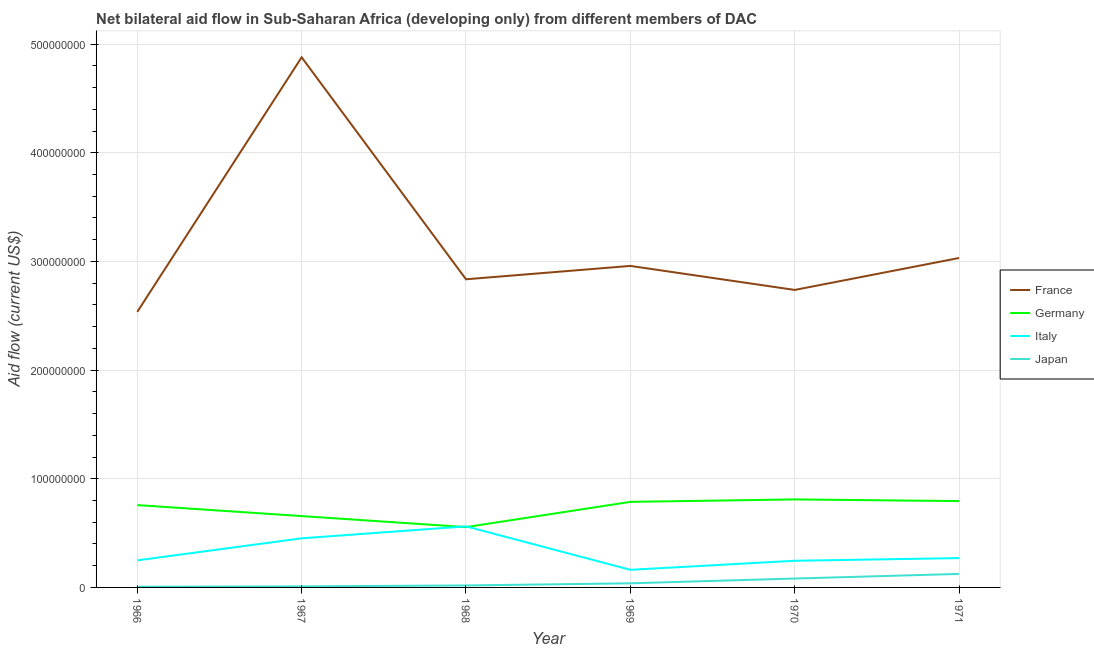How many different coloured lines are there?
Make the answer very short. 4. Is the number of lines equal to the number of legend labels?
Keep it short and to the point. Yes. What is the amount of aid given by italy in 1971?
Provide a succinct answer. 2.70e+07. Across all years, what is the maximum amount of aid given by france?
Your response must be concise. 4.88e+08. Across all years, what is the minimum amount of aid given by germany?
Provide a succinct answer. 5.55e+07. In which year was the amount of aid given by france maximum?
Provide a succinct answer. 1967. In which year was the amount of aid given by germany minimum?
Provide a short and direct response. 1968. What is the total amount of aid given by italy in the graph?
Offer a terse response. 1.94e+08. What is the difference between the amount of aid given by japan in 1966 and that in 1971?
Keep it short and to the point. -1.18e+07. What is the difference between the amount of aid given by france in 1971 and the amount of aid given by germany in 1968?
Offer a terse response. 2.48e+08. What is the average amount of aid given by italy per year?
Offer a very short reply. 3.23e+07. In the year 1967, what is the difference between the amount of aid given by italy and amount of aid given by japan?
Your answer should be compact. 4.42e+07. In how many years, is the amount of aid given by germany greater than 400000000 US$?
Give a very brief answer. 0. What is the ratio of the amount of aid given by france in 1967 to that in 1969?
Offer a terse response. 1.65. Is the amount of aid given by germany in 1969 less than that in 1971?
Provide a short and direct response. Yes. What is the difference between the highest and the second highest amount of aid given by japan?
Provide a short and direct response. 4.24e+06. What is the difference between the highest and the lowest amount of aid given by italy?
Give a very brief answer. 4.00e+07. Is the sum of the amount of aid given by germany in 1970 and 1971 greater than the maximum amount of aid given by italy across all years?
Provide a short and direct response. Yes. Is it the case that in every year, the sum of the amount of aid given by japan and amount of aid given by germany is greater than the sum of amount of aid given by italy and amount of aid given by france?
Your response must be concise. No. Is it the case that in every year, the sum of the amount of aid given by france and amount of aid given by germany is greater than the amount of aid given by italy?
Make the answer very short. Yes. Does the amount of aid given by japan monotonically increase over the years?
Your answer should be very brief. Yes. Is the amount of aid given by germany strictly greater than the amount of aid given by japan over the years?
Your answer should be compact. Yes. How many lines are there?
Ensure brevity in your answer.  4. How are the legend labels stacked?
Provide a succinct answer. Vertical. What is the title of the graph?
Give a very brief answer. Net bilateral aid flow in Sub-Saharan Africa (developing only) from different members of DAC. Does "Source data assessment" appear as one of the legend labels in the graph?
Offer a very short reply. No. What is the label or title of the X-axis?
Offer a terse response. Year. What is the label or title of the Y-axis?
Make the answer very short. Aid flow (current US$). What is the Aid flow (current US$) in France in 1966?
Ensure brevity in your answer.  2.54e+08. What is the Aid flow (current US$) of Germany in 1966?
Provide a short and direct response. 7.58e+07. What is the Aid flow (current US$) of Italy in 1966?
Make the answer very short. 2.49e+07. What is the Aid flow (current US$) of Japan in 1966?
Your response must be concise. 6.60e+05. What is the Aid flow (current US$) in France in 1967?
Provide a succinct answer. 4.88e+08. What is the Aid flow (current US$) of Germany in 1967?
Make the answer very short. 6.57e+07. What is the Aid flow (current US$) in Italy in 1967?
Give a very brief answer. 4.52e+07. What is the Aid flow (current US$) in Japan in 1967?
Offer a terse response. 9.70e+05. What is the Aid flow (current US$) of France in 1968?
Offer a terse response. 2.84e+08. What is the Aid flow (current US$) of Germany in 1968?
Offer a terse response. 5.55e+07. What is the Aid flow (current US$) of Italy in 1968?
Provide a short and direct response. 5.62e+07. What is the Aid flow (current US$) in Japan in 1968?
Your answer should be compact. 1.82e+06. What is the Aid flow (current US$) in France in 1969?
Provide a short and direct response. 2.96e+08. What is the Aid flow (current US$) in Germany in 1969?
Provide a short and direct response. 7.88e+07. What is the Aid flow (current US$) in Italy in 1969?
Provide a short and direct response. 1.62e+07. What is the Aid flow (current US$) in Japan in 1969?
Your response must be concise. 3.79e+06. What is the Aid flow (current US$) in France in 1970?
Your response must be concise. 2.74e+08. What is the Aid flow (current US$) of Germany in 1970?
Provide a succinct answer. 8.10e+07. What is the Aid flow (current US$) in Italy in 1970?
Offer a very short reply. 2.45e+07. What is the Aid flow (current US$) of Japan in 1970?
Make the answer very short. 8.19e+06. What is the Aid flow (current US$) of France in 1971?
Your answer should be very brief. 3.03e+08. What is the Aid flow (current US$) in Germany in 1971?
Provide a short and direct response. 7.94e+07. What is the Aid flow (current US$) in Italy in 1971?
Your response must be concise. 2.70e+07. What is the Aid flow (current US$) of Japan in 1971?
Provide a succinct answer. 1.24e+07. Across all years, what is the maximum Aid flow (current US$) of France?
Your answer should be very brief. 4.88e+08. Across all years, what is the maximum Aid flow (current US$) of Germany?
Your answer should be compact. 8.10e+07. Across all years, what is the maximum Aid flow (current US$) of Italy?
Provide a succinct answer. 5.62e+07. Across all years, what is the maximum Aid flow (current US$) in Japan?
Give a very brief answer. 1.24e+07. Across all years, what is the minimum Aid flow (current US$) of France?
Give a very brief answer. 2.54e+08. Across all years, what is the minimum Aid flow (current US$) in Germany?
Offer a terse response. 5.55e+07. Across all years, what is the minimum Aid flow (current US$) in Italy?
Provide a succinct answer. 1.62e+07. Across all years, what is the minimum Aid flow (current US$) in Japan?
Ensure brevity in your answer.  6.60e+05. What is the total Aid flow (current US$) of France in the graph?
Provide a short and direct response. 1.90e+09. What is the total Aid flow (current US$) in Germany in the graph?
Your response must be concise. 4.36e+08. What is the total Aid flow (current US$) in Italy in the graph?
Provide a short and direct response. 1.94e+08. What is the total Aid flow (current US$) of Japan in the graph?
Keep it short and to the point. 2.79e+07. What is the difference between the Aid flow (current US$) in France in 1966 and that in 1967?
Offer a terse response. -2.34e+08. What is the difference between the Aid flow (current US$) of Germany in 1966 and that in 1967?
Give a very brief answer. 1.01e+07. What is the difference between the Aid flow (current US$) in Italy in 1966 and that in 1967?
Keep it short and to the point. -2.03e+07. What is the difference between the Aid flow (current US$) in Japan in 1966 and that in 1967?
Keep it short and to the point. -3.10e+05. What is the difference between the Aid flow (current US$) of France in 1966 and that in 1968?
Ensure brevity in your answer.  -3.00e+07. What is the difference between the Aid flow (current US$) of Germany in 1966 and that in 1968?
Offer a terse response. 2.03e+07. What is the difference between the Aid flow (current US$) of Italy in 1966 and that in 1968?
Offer a terse response. -3.13e+07. What is the difference between the Aid flow (current US$) of Japan in 1966 and that in 1968?
Ensure brevity in your answer.  -1.16e+06. What is the difference between the Aid flow (current US$) in France in 1966 and that in 1969?
Your answer should be very brief. -4.23e+07. What is the difference between the Aid flow (current US$) of Germany in 1966 and that in 1969?
Keep it short and to the point. -2.97e+06. What is the difference between the Aid flow (current US$) in Italy in 1966 and that in 1969?
Ensure brevity in your answer.  8.69e+06. What is the difference between the Aid flow (current US$) of Japan in 1966 and that in 1969?
Your answer should be very brief. -3.13e+06. What is the difference between the Aid flow (current US$) of France in 1966 and that in 1970?
Provide a short and direct response. -2.02e+07. What is the difference between the Aid flow (current US$) of Germany in 1966 and that in 1970?
Provide a succinct answer. -5.22e+06. What is the difference between the Aid flow (current US$) of Italy in 1966 and that in 1970?
Provide a succinct answer. 3.80e+05. What is the difference between the Aid flow (current US$) in Japan in 1966 and that in 1970?
Keep it short and to the point. -7.53e+06. What is the difference between the Aid flow (current US$) in France in 1966 and that in 1971?
Provide a short and direct response. -4.96e+07. What is the difference between the Aid flow (current US$) of Germany in 1966 and that in 1971?
Your answer should be very brief. -3.67e+06. What is the difference between the Aid flow (current US$) in Italy in 1966 and that in 1971?
Give a very brief answer. -2.08e+06. What is the difference between the Aid flow (current US$) of Japan in 1966 and that in 1971?
Offer a terse response. -1.18e+07. What is the difference between the Aid flow (current US$) in France in 1967 and that in 1968?
Your answer should be compact. 2.04e+08. What is the difference between the Aid flow (current US$) in Germany in 1967 and that in 1968?
Your answer should be very brief. 1.02e+07. What is the difference between the Aid flow (current US$) of Italy in 1967 and that in 1968?
Make the answer very short. -1.10e+07. What is the difference between the Aid flow (current US$) in Japan in 1967 and that in 1968?
Your answer should be very brief. -8.50e+05. What is the difference between the Aid flow (current US$) in France in 1967 and that in 1969?
Your response must be concise. 1.92e+08. What is the difference between the Aid flow (current US$) in Germany in 1967 and that in 1969?
Make the answer very short. -1.31e+07. What is the difference between the Aid flow (current US$) of Italy in 1967 and that in 1969?
Give a very brief answer. 2.90e+07. What is the difference between the Aid flow (current US$) of Japan in 1967 and that in 1969?
Give a very brief answer. -2.82e+06. What is the difference between the Aid flow (current US$) of France in 1967 and that in 1970?
Your answer should be compact. 2.14e+08. What is the difference between the Aid flow (current US$) in Germany in 1967 and that in 1970?
Make the answer very short. -1.53e+07. What is the difference between the Aid flow (current US$) in Italy in 1967 and that in 1970?
Your answer should be compact. 2.07e+07. What is the difference between the Aid flow (current US$) in Japan in 1967 and that in 1970?
Offer a very short reply. -7.22e+06. What is the difference between the Aid flow (current US$) of France in 1967 and that in 1971?
Your answer should be compact. 1.85e+08. What is the difference between the Aid flow (current US$) of Germany in 1967 and that in 1971?
Give a very brief answer. -1.38e+07. What is the difference between the Aid flow (current US$) in Italy in 1967 and that in 1971?
Offer a terse response. 1.82e+07. What is the difference between the Aid flow (current US$) in Japan in 1967 and that in 1971?
Your answer should be compact. -1.15e+07. What is the difference between the Aid flow (current US$) in France in 1968 and that in 1969?
Offer a terse response. -1.23e+07. What is the difference between the Aid flow (current US$) in Germany in 1968 and that in 1969?
Give a very brief answer. -2.32e+07. What is the difference between the Aid flow (current US$) in Italy in 1968 and that in 1969?
Your answer should be very brief. 4.00e+07. What is the difference between the Aid flow (current US$) of Japan in 1968 and that in 1969?
Ensure brevity in your answer.  -1.97e+06. What is the difference between the Aid flow (current US$) of France in 1968 and that in 1970?
Provide a succinct answer. 9.80e+06. What is the difference between the Aid flow (current US$) in Germany in 1968 and that in 1970?
Ensure brevity in your answer.  -2.55e+07. What is the difference between the Aid flow (current US$) in Italy in 1968 and that in 1970?
Provide a succinct answer. 3.17e+07. What is the difference between the Aid flow (current US$) of Japan in 1968 and that in 1970?
Give a very brief answer. -6.37e+06. What is the difference between the Aid flow (current US$) in France in 1968 and that in 1971?
Offer a very short reply. -1.96e+07. What is the difference between the Aid flow (current US$) of Germany in 1968 and that in 1971?
Give a very brief answer. -2.39e+07. What is the difference between the Aid flow (current US$) in Italy in 1968 and that in 1971?
Provide a succinct answer. 2.92e+07. What is the difference between the Aid flow (current US$) of Japan in 1968 and that in 1971?
Keep it short and to the point. -1.06e+07. What is the difference between the Aid flow (current US$) in France in 1969 and that in 1970?
Provide a succinct answer. 2.21e+07. What is the difference between the Aid flow (current US$) in Germany in 1969 and that in 1970?
Your answer should be very brief. -2.25e+06. What is the difference between the Aid flow (current US$) of Italy in 1969 and that in 1970?
Offer a very short reply. -8.31e+06. What is the difference between the Aid flow (current US$) in Japan in 1969 and that in 1970?
Give a very brief answer. -4.40e+06. What is the difference between the Aid flow (current US$) in France in 1969 and that in 1971?
Make the answer very short. -7.30e+06. What is the difference between the Aid flow (current US$) in Germany in 1969 and that in 1971?
Offer a terse response. -7.00e+05. What is the difference between the Aid flow (current US$) of Italy in 1969 and that in 1971?
Give a very brief answer. -1.08e+07. What is the difference between the Aid flow (current US$) in Japan in 1969 and that in 1971?
Your response must be concise. -8.64e+06. What is the difference between the Aid flow (current US$) in France in 1970 and that in 1971?
Offer a very short reply. -2.94e+07. What is the difference between the Aid flow (current US$) of Germany in 1970 and that in 1971?
Your answer should be very brief. 1.55e+06. What is the difference between the Aid flow (current US$) in Italy in 1970 and that in 1971?
Keep it short and to the point. -2.46e+06. What is the difference between the Aid flow (current US$) of Japan in 1970 and that in 1971?
Ensure brevity in your answer.  -4.24e+06. What is the difference between the Aid flow (current US$) in France in 1966 and the Aid flow (current US$) in Germany in 1967?
Your answer should be very brief. 1.88e+08. What is the difference between the Aid flow (current US$) in France in 1966 and the Aid flow (current US$) in Italy in 1967?
Make the answer very short. 2.08e+08. What is the difference between the Aid flow (current US$) in France in 1966 and the Aid flow (current US$) in Japan in 1967?
Provide a short and direct response. 2.53e+08. What is the difference between the Aid flow (current US$) in Germany in 1966 and the Aid flow (current US$) in Italy in 1967?
Your response must be concise. 3.06e+07. What is the difference between the Aid flow (current US$) in Germany in 1966 and the Aid flow (current US$) in Japan in 1967?
Provide a short and direct response. 7.48e+07. What is the difference between the Aid flow (current US$) in Italy in 1966 and the Aid flow (current US$) in Japan in 1967?
Offer a very short reply. 2.40e+07. What is the difference between the Aid flow (current US$) in France in 1966 and the Aid flow (current US$) in Germany in 1968?
Keep it short and to the point. 1.98e+08. What is the difference between the Aid flow (current US$) in France in 1966 and the Aid flow (current US$) in Italy in 1968?
Offer a terse response. 1.97e+08. What is the difference between the Aid flow (current US$) in France in 1966 and the Aid flow (current US$) in Japan in 1968?
Give a very brief answer. 2.52e+08. What is the difference between the Aid flow (current US$) in Germany in 1966 and the Aid flow (current US$) in Italy in 1968?
Ensure brevity in your answer.  1.96e+07. What is the difference between the Aid flow (current US$) in Germany in 1966 and the Aid flow (current US$) in Japan in 1968?
Offer a very short reply. 7.40e+07. What is the difference between the Aid flow (current US$) in Italy in 1966 and the Aid flow (current US$) in Japan in 1968?
Offer a terse response. 2.31e+07. What is the difference between the Aid flow (current US$) in France in 1966 and the Aid flow (current US$) in Germany in 1969?
Keep it short and to the point. 1.75e+08. What is the difference between the Aid flow (current US$) in France in 1966 and the Aid flow (current US$) in Italy in 1969?
Give a very brief answer. 2.37e+08. What is the difference between the Aid flow (current US$) of France in 1966 and the Aid flow (current US$) of Japan in 1969?
Your answer should be very brief. 2.50e+08. What is the difference between the Aid flow (current US$) in Germany in 1966 and the Aid flow (current US$) in Italy in 1969?
Your answer should be compact. 5.96e+07. What is the difference between the Aid flow (current US$) in Germany in 1966 and the Aid flow (current US$) in Japan in 1969?
Offer a terse response. 7.20e+07. What is the difference between the Aid flow (current US$) of Italy in 1966 and the Aid flow (current US$) of Japan in 1969?
Make the answer very short. 2.11e+07. What is the difference between the Aid flow (current US$) in France in 1966 and the Aid flow (current US$) in Germany in 1970?
Provide a succinct answer. 1.73e+08. What is the difference between the Aid flow (current US$) of France in 1966 and the Aid flow (current US$) of Italy in 1970?
Keep it short and to the point. 2.29e+08. What is the difference between the Aid flow (current US$) of France in 1966 and the Aid flow (current US$) of Japan in 1970?
Keep it short and to the point. 2.45e+08. What is the difference between the Aid flow (current US$) in Germany in 1966 and the Aid flow (current US$) in Italy in 1970?
Your answer should be very brief. 5.12e+07. What is the difference between the Aid flow (current US$) in Germany in 1966 and the Aid flow (current US$) in Japan in 1970?
Keep it short and to the point. 6.76e+07. What is the difference between the Aid flow (current US$) of Italy in 1966 and the Aid flow (current US$) of Japan in 1970?
Your answer should be compact. 1.67e+07. What is the difference between the Aid flow (current US$) in France in 1966 and the Aid flow (current US$) in Germany in 1971?
Give a very brief answer. 1.74e+08. What is the difference between the Aid flow (current US$) of France in 1966 and the Aid flow (current US$) of Italy in 1971?
Your response must be concise. 2.27e+08. What is the difference between the Aid flow (current US$) in France in 1966 and the Aid flow (current US$) in Japan in 1971?
Your answer should be compact. 2.41e+08. What is the difference between the Aid flow (current US$) in Germany in 1966 and the Aid flow (current US$) in Italy in 1971?
Offer a terse response. 4.88e+07. What is the difference between the Aid flow (current US$) in Germany in 1966 and the Aid flow (current US$) in Japan in 1971?
Your answer should be compact. 6.34e+07. What is the difference between the Aid flow (current US$) of Italy in 1966 and the Aid flow (current US$) of Japan in 1971?
Offer a terse response. 1.25e+07. What is the difference between the Aid flow (current US$) in France in 1967 and the Aid flow (current US$) in Germany in 1968?
Ensure brevity in your answer.  4.32e+08. What is the difference between the Aid flow (current US$) in France in 1967 and the Aid flow (current US$) in Italy in 1968?
Ensure brevity in your answer.  4.32e+08. What is the difference between the Aid flow (current US$) in France in 1967 and the Aid flow (current US$) in Japan in 1968?
Give a very brief answer. 4.86e+08. What is the difference between the Aid flow (current US$) of Germany in 1967 and the Aid flow (current US$) of Italy in 1968?
Your answer should be compact. 9.46e+06. What is the difference between the Aid flow (current US$) in Germany in 1967 and the Aid flow (current US$) in Japan in 1968?
Your response must be concise. 6.38e+07. What is the difference between the Aid flow (current US$) of Italy in 1967 and the Aid flow (current US$) of Japan in 1968?
Provide a short and direct response. 4.34e+07. What is the difference between the Aid flow (current US$) in France in 1967 and the Aid flow (current US$) in Germany in 1969?
Your answer should be very brief. 4.09e+08. What is the difference between the Aid flow (current US$) in France in 1967 and the Aid flow (current US$) in Italy in 1969?
Give a very brief answer. 4.72e+08. What is the difference between the Aid flow (current US$) of France in 1967 and the Aid flow (current US$) of Japan in 1969?
Your response must be concise. 4.84e+08. What is the difference between the Aid flow (current US$) of Germany in 1967 and the Aid flow (current US$) of Italy in 1969?
Provide a succinct answer. 4.94e+07. What is the difference between the Aid flow (current US$) in Germany in 1967 and the Aid flow (current US$) in Japan in 1969?
Make the answer very short. 6.19e+07. What is the difference between the Aid flow (current US$) in Italy in 1967 and the Aid flow (current US$) in Japan in 1969?
Offer a terse response. 4.14e+07. What is the difference between the Aid flow (current US$) in France in 1967 and the Aid flow (current US$) in Germany in 1970?
Your response must be concise. 4.07e+08. What is the difference between the Aid flow (current US$) of France in 1967 and the Aid flow (current US$) of Italy in 1970?
Ensure brevity in your answer.  4.63e+08. What is the difference between the Aid flow (current US$) in France in 1967 and the Aid flow (current US$) in Japan in 1970?
Your answer should be compact. 4.80e+08. What is the difference between the Aid flow (current US$) in Germany in 1967 and the Aid flow (current US$) in Italy in 1970?
Ensure brevity in your answer.  4.11e+07. What is the difference between the Aid flow (current US$) of Germany in 1967 and the Aid flow (current US$) of Japan in 1970?
Your answer should be very brief. 5.75e+07. What is the difference between the Aid flow (current US$) of Italy in 1967 and the Aid flow (current US$) of Japan in 1970?
Your response must be concise. 3.70e+07. What is the difference between the Aid flow (current US$) of France in 1967 and the Aid flow (current US$) of Germany in 1971?
Offer a very short reply. 4.08e+08. What is the difference between the Aid flow (current US$) of France in 1967 and the Aid flow (current US$) of Italy in 1971?
Offer a terse response. 4.61e+08. What is the difference between the Aid flow (current US$) of France in 1967 and the Aid flow (current US$) of Japan in 1971?
Your answer should be very brief. 4.75e+08. What is the difference between the Aid flow (current US$) in Germany in 1967 and the Aid flow (current US$) in Italy in 1971?
Your answer should be compact. 3.87e+07. What is the difference between the Aid flow (current US$) of Germany in 1967 and the Aid flow (current US$) of Japan in 1971?
Provide a succinct answer. 5.32e+07. What is the difference between the Aid flow (current US$) of Italy in 1967 and the Aid flow (current US$) of Japan in 1971?
Make the answer very short. 3.28e+07. What is the difference between the Aid flow (current US$) of France in 1968 and the Aid flow (current US$) of Germany in 1969?
Ensure brevity in your answer.  2.05e+08. What is the difference between the Aid flow (current US$) of France in 1968 and the Aid flow (current US$) of Italy in 1969?
Provide a short and direct response. 2.67e+08. What is the difference between the Aid flow (current US$) of France in 1968 and the Aid flow (current US$) of Japan in 1969?
Make the answer very short. 2.80e+08. What is the difference between the Aid flow (current US$) in Germany in 1968 and the Aid flow (current US$) in Italy in 1969?
Offer a terse response. 3.93e+07. What is the difference between the Aid flow (current US$) of Germany in 1968 and the Aid flow (current US$) of Japan in 1969?
Offer a terse response. 5.17e+07. What is the difference between the Aid flow (current US$) in Italy in 1968 and the Aid flow (current US$) in Japan in 1969?
Your answer should be very brief. 5.24e+07. What is the difference between the Aid flow (current US$) in France in 1968 and the Aid flow (current US$) in Germany in 1970?
Give a very brief answer. 2.03e+08. What is the difference between the Aid flow (current US$) of France in 1968 and the Aid flow (current US$) of Italy in 1970?
Your answer should be compact. 2.59e+08. What is the difference between the Aid flow (current US$) of France in 1968 and the Aid flow (current US$) of Japan in 1970?
Your answer should be compact. 2.75e+08. What is the difference between the Aid flow (current US$) of Germany in 1968 and the Aid flow (current US$) of Italy in 1970?
Your answer should be compact. 3.10e+07. What is the difference between the Aid flow (current US$) of Germany in 1968 and the Aid flow (current US$) of Japan in 1970?
Make the answer very short. 4.73e+07. What is the difference between the Aid flow (current US$) in Italy in 1968 and the Aid flow (current US$) in Japan in 1970?
Your answer should be compact. 4.80e+07. What is the difference between the Aid flow (current US$) in France in 1968 and the Aid flow (current US$) in Germany in 1971?
Provide a short and direct response. 2.04e+08. What is the difference between the Aid flow (current US$) in France in 1968 and the Aid flow (current US$) in Italy in 1971?
Provide a succinct answer. 2.57e+08. What is the difference between the Aid flow (current US$) in France in 1968 and the Aid flow (current US$) in Japan in 1971?
Keep it short and to the point. 2.71e+08. What is the difference between the Aid flow (current US$) of Germany in 1968 and the Aid flow (current US$) of Italy in 1971?
Your answer should be compact. 2.85e+07. What is the difference between the Aid flow (current US$) in Germany in 1968 and the Aid flow (current US$) in Japan in 1971?
Offer a terse response. 4.31e+07. What is the difference between the Aid flow (current US$) of Italy in 1968 and the Aid flow (current US$) of Japan in 1971?
Make the answer very short. 4.38e+07. What is the difference between the Aid flow (current US$) of France in 1969 and the Aid flow (current US$) of Germany in 1970?
Provide a short and direct response. 2.15e+08. What is the difference between the Aid flow (current US$) in France in 1969 and the Aid flow (current US$) in Italy in 1970?
Provide a succinct answer. 2.71e+08. What is the difference between the Aid flow (current US$) in France in 1969 and the Aid flow (current US$) in Japan in 1970?
Offer a terse response. 2.88e+08. What is the difference between the Aid flow (current US$) in Germany in 1969 and the Aid flow (current US$) in Italy in 1970?
Offer a terse response. 5.42e+07. What is the difference between the Aid flow (current US$) of Germany in 1969 and the Aid flow (current US$) of Japan in 1970?
Your answer should be very brief. 7.06e+07. What is the difference between the Aid flow (current US$) of Italy in 1969 and the Aid flow (current US$) of Japan in 1970?
Your answer should be very brief. 8.04e+06. What is the difference between the Aid flow (current US$) of France in 1969 and the Aid flow (current US$) of Germany in 1971?
Provide a short and direct response. 2.16e+08. What is the difference between the Aid flow (current US$) in France in 1969 and the Aid flow (current US$) in Italy in 1971?
Provide a short and direct response. 2.69e+08. What is the difference between the Aid flow (current US$) in France in 1969 and the Aid flow (current US$) in Japan in 1971?
Offer a very short reply. 2.83e+08. What is the difference between the Aid flow (current US$) of Germany in 1969 and the Aid flow (current US$) of Italy in 1971?
Your answer should be very brief. 5.18e+07. What is the difference between the Aid flow (current US$) in Germany in 1969 and the Aid flow (current US$) in Japan in 1971?
Offer a very short reply. 6.63e+07. What is the difference between the Aid flow (current US$) in Italy in 1969 and the Aid flow (current US$) in Japan in 1971?
Provide a succinct answer. 3.80e+06. What is the difference between the Aid flow (current US$) of France in 1970 and the Aid flow (current US$) of Germany in 1971?
Your answer should be very brief. 1.94e+08. What is the difference between the Aid flow (current US$) of France in 1970 and the Aid flow (current US$) of Italy in 1971?
Make the answer very short. 2.47e+08. What is the difference between the Aid flow (current US$) in France in 1970 and the Aid flow (current US$) in Japan in 1971?
Your response must be concise. 2.61e+08. What is the difference between the Aid flow (current US$) of Germany in 1970 and the Aid flow (current US$) of Italy in 1971?
Provide a short and direct response. 5.40e+07. What is the difference between the Aid flow (current US$) of Germany in 1970 and the Aid flow (current US$) of Japan in 1971?
Give a very brief answer. 6.86e+07. What is the difference between the Aid flow (current US$) of Italy in 1970 and the Aid flow (current US$) of Japan in 1971?
Your answer should be compact. 1.21e+07. What is the average Aid flow (current US$) of France per year?
Your answer should be very brief. 3.16e+08. What is the average Aid flow (current US$) in Germany per year?
Offer a very short reply. 7.27e+07. What is the average Aid flow (current US$) of Italy per year?
Give a very brief answer. 3.23e+07. What is the average Aid flow (current US$) in Japan per year?
Ensure brevity in your answer.  4.64e+06. In the year 1966, what is the difference between the Aid flow (current US$) in France and Aid flow (current US$) in Germany?
Offer a terse response. 1.78e+08. In the year 1966, what is the difference between the Aid flow (current US$) of France and Aid flow (current US$) of Italy?
Your response must be concise. 2.29e+08. In the year 1966, what is the difference between the Aid flow (current US$) of France and Aid flow (current US$) of Japan?
Your answer should be very brief. 2.53e+08. In the year 1966, what is the difference between the Aid flow (current US$) in Germany and Aid flow (current US$) in Italy?
Keep it short and to the point. 5.09e+07. In the year 1966, what is the difference between the Aid flow (current US$) of Germany and Aid flow (current US$) of Japan?
Your answer should be compact. 7.51e+07. In the year 1966, what is the difference between the Aid flow (current US$) in Italy and Aid flow (current US$) in Japan?
Your answer should be compact. 2.43e+07. In the year 1967, what is the difference between the Aid flow (current US$) in France and Aid flow (current US$) in Germany?
Offer a terse response. 4.22e+08. In the year 1967, what is the difference between the Aid flow (current US$) of France and Aid flow (current US$) of Italy?
Your answer should be compact. 4.43e+08. In the year 1967, what is the difference between the Aid flow (current US$) of France and Aid flow (current US$) of Japan?
Your answer should be compact. 4.87e+08. In the year 1967, what is the difference between the Aid flow (current US$) in Germany and Aid flow (current US$) in Italy?
Offer a very short reply. 2.05e+07. In the year 1967, what is the difference between the Aid flow (current US$) in Germany and Aid flow (current US$) in Japan?
Offer a terse response. 6.47e+07. In the year 1967, what is the difference between the Aid flow (current US$) of Italy and Aid flow (current US$) of Japan?
Offer a terse response. 4.42e+07. In the year 1968, what is the difference between the Aid flow (current US$) in France and Aid flow (current US$) in Germany?
Provide a short and direct response. 2.28e+08. In the year 1968, what is the difference between the Aid flow (current US$) in France and Aid flow (current US$) in Italy?
Ensure brevity in your answer.  2.27e+08. In the year 1968, what is the difference between the Aid flow (current US$) of France and Aid flow (current US$) of Japan?
Your answer should be very brief. 2.82e+08. In the year 1968, what is the difference between the Aid flow (current US$) in Germany and Aid flow (current US$) in Italy?
Provide a succinct answer. -6.90e+05. In the year 1968, what is the difference between the Aid flow (current US$) of Germany and Aid flow (current US$) of Japan?
Provide a succinct answer. 5.37e+07. In the year 1968, what is the difference between the Aid flow (current US$) of Italy and Aid flow (current US$) of Japan?
Keep it short and to the point. 5.44e+07. In the year 1969, what is the difference between the Aid flow (current US$) of France and Aid flow (current US$) of Germany?
Provide a short and direct response. 2.17e+08. In the year 1969, what is the difference between the Aid flow (current US$) of France and Aid flow (current US$) of Italy?
Ensure brevity in your answer.  2.80e+08. In the year 1969, what is the difference between the Aid flow (current US$) in France and Aid flow (current US$) in Japan?
Your response must be concise. 2.92e+08. In the year 1969, what is the difference between the Aid flow (current US$) in Germany and Aid flow (current US$) in Italy?
Your answer should be very brief. 6.25e+07. In the year 1969, what is the difference between the Aid flow (current US$) in Germany and Aid flow (current US$) in Japan?
Your response must be concise. 7.50e+07. In the year 1969, what is the difference between the Aid flow (current US$) of Italy and Aid flow (current US$) of Japan?
Make the answer very short. 1.24e+07. In the year 1970, what is the difference between the Aid flow (current US$) of France and Aid flow (current US$) of Germany?
Provide a succinct answer. 1.93e+08. In the year 1970, what is the difference between the Aid flow (current US$) in France and Aid flow (current US$) in Italy?
Provide a short and direct response. 2.49e+08. In the year 1970, what is the difference between the Aid flow (current US$) in France and Aid flow (current US$) in Japan?
Your answer should be compact. 2.66e+08. In the year 1970, what is the difference between the Aid flow (current US$) in Germany and Aid flow (current US$) in Italy?
Provide a short and direct response. 5.65e+07. In the year 1970, what is the difference between the Aid flow (current US$) in Germany and Aid flow (current US$) in Japan?
Offer a terse response. 7.28e+07. In the year 1970, what is the difference between the Aid flow (current US$) in Italy and Aid flow (current US$) in Japan?
Your response must be concise. 1.64e+07. In the year 1971, what is the difference between the Aid flow (current US$) of France and Aid flow (current US$) of Germany?
Offer a very short reply. 2.24e+08. In the year 1971, what is the difference between the Aid flow (current US$) in France and Aid flow (current US$) in Italy?
Keep it short and to the point. 2.76e+08. In the year 1971, what is the difference between the Aid flow (current US$) in France and Aid flow (current US$) in Japan?
Give a very brief answer. 2.91e+08. In the year 1971, what is the difference between the Aid flow (current US$) of Germany and Aid flow (current US$) of Italy?
Provide a short and direct response. 5.24e+07. In the year 1971, what is the difference between the Aid flow (current US$) of Germany and Aid flow (current US$) of Japan?
Your answer should be compact. 6.70e+07. In the year 1971, what is the difference between the Aid flow (current US$) in Italy and Aid flow (current US$) in Japan?
Offer a terse response. 1.46e+07. What is the ratio of the Aid flow (current US$) of France in 1966 to that in 1967?
Provide a succinct answer. 0.52. What is the ratio of the Aid flow (current US$) in Germany in 1966 to that in 1967?
Make the answer very short. 1.15. What is the ratio of the Aid flow (current US$) of Italy in 1966 to that in 1967?
Make the answer very short. 0.55. What is the ratio of the Aid flow (current US$) of Japan in 1966 to that in 1967?
Your response must be concise. 0.68. What is the ratio of the Aid flow (current US$) in France in 1966 to that in 1968?
Your response must be concise. 0.89. What is the ratio of the Aid flow (current US$) in Germany in 1966 to that in 1968?
Offer a terse response. 1.37. What is the ratio of the Aid flow (current US$) of Italy in 1966 to that in 1968?
Offer a terse response. 0.44. What is the ratio of the Aid flow (current US$) in Japan in 1966 to that in 1968?
Offer a very short reply. 0.36. What is the ratio of the Aid flow (current US$) in France in 1966 to that in 1969?
Provide a short and direct response. 0.86. What is the ratio of the Aid flow (current US$) of Germany in 1966 to that in 1969?
Give a very brief answer. 0.96. What is the ratio of the Aid flow (current US$) of Italy in 1966 to that in 1969?
Keep it short and to the point. 1.54. What is the ratio of the Aid flow (current US$) in Japan in 1966 to that in 1969?
Offer a terse response. 0.17. What is the ratio of the Aid flow (current US$) of France in 1966 to that in 1970?
Offer a terse response. 0.93. What is the ratio of the Aid flow (current US$) in Germany in 1966 to that in 1970?
Offer a terse response. 0.94. What is the ratio of the Aid flow (current US$) of Italy in 1966 to that in 1970?
Your response must be concise. 1.02. What is the ratio of the Aid flow (current US$) of Japan in 1966 to that in 1970?
Ensure brevity in your answer.  0.08. What is the ratio of the Aid flow (current US$) of France in 1966 to that in 1971?
Keep it short and to the point. 0.84. What is the ratio of the Aid flow (current US$) of Germany in 1966 to that in 1971?
Offer a terse response. 0.95. What is the ratio of the Aid flow (current US$) of Italy in 1966 to that in 1971?
Offer a very short reply. 0.92. What is the ratio of the Aid flow (current US$) in Japan in 1966 to that in 1971?
Provide a succinct answer. 0.05. What is the ratio of the Aid flow (current US$) of France in 1967 to that in 1968?
Your answer should be compact. 1.72. What is the ratio of the Aid flow (current US$) in Germany in 1967 to that in 1968?
Your answer should be very brief. 1.18. What is the ratio of the Aid flow (current US$) of Italy in 1967 to that in 1968?
Provide a succinct answer. 0.8. What is the ratio of the Aid flow (current US$) of Japan in 1967 to that in 1968?
Keep it short and to the point. 0.53. What is the ratio of the Aid flow (current US$) in France in 1967 to that in 1969?
Give a very brief answer. 1.65. What is the ratio of the Aid flow (current US$) of Germany in 1967 to that in 1969?
Offer a very short reply. 0.83. What is the ratio of the Aid flow (current US$) in Italy in 1967 to that in 1969?
Make the answer very short. 2.79. What is the ratio of the Aid flow (current US$) of Japan in 1967 to that in 1969?
Give a very brief answer. 0.26. What is the ratio of the Aid flow (current US$) in France in 1967 to that in 1970?
Your answer should be very brief. 1.78. What is the ratio of the Aid flow (current US$) of Germany in 1967 to that in 1970?
Give a very brief answer. 0.81. What is the ratio of the Aid flow (current US$) of Italy in 1967 to that in 1970?
Give a very brief answer. 1.84. What is the ratio of the Aid flow (current US$) in Japan in 1967 to that in 1970?
Ensure brevity in your answer.  0.12. What is the ratio of the Aid flow (current US$) in France in 1967 to that in 1971?
Give a very brief answer. 1.61. What is the ratio of the Aid flow (current US$) of Germany in 1967 to that in 1971?
Offer a very short reply. 0.83. What is the ratio of the Aid flow (current US$) in Italy in 1967 to that in 1971?
Offer a terse response. 1.67. What is the ratio of the Aid flow (current US$) in Japan in 1967 to that in 1971?
Provide a short and direct response. 0.08. What is the ratio of the Aid flow (current US$) of France in 1968 to that in 1969?
Provide a short and direct response. 0.96. What is the ratio of the Aid flow (current US$) of Germany in 1968 to that in 1969?
Offer a very short reply. 0.7. What is the ratio of the Aid flow (current US$) in Italy in 1968 to that in 1969?
Keep it short and to the point. 3.46. What is the ratio of the Aid flow (current US$) of Japan in 1968 to that in 1969?
Offer a terse response. 0.48. What is the ratio of the Aid flow (current US$) in France in 1968 to that in 1970?
Make the answer very short. 1.04. What is the ratio of the Aid flow (current US$) of Germany in 1968 to that in 1970?
Provide a short and direct response. 0.69. What is the ratio of the Aid flow (current US$) in Italy in 1968 to that in 1970?
Make the answer very short. 2.29. What is the ratio of the Aid flow (current US$) of Japan in 1968 to that in 1970?
Your response must be concise. 0.22. What is the ratio of the Aid flow (current US$) in France in 1968 to that in 1971?
Make the answer very short. 0.94. What is the ratio of the Aid flow (current US$) in Germany in 1968 to that in 1971?
Ensure brevity in your answer.  0.7. What is the ratio of the Aid flow (current US$) in Italy in 1968 to that in 1971?
Your response must be concise. 2.08. What is the ratio of the Aid flow (current US$) of Japan in 1968 to that in 1971?
Your response must be concise. 0.15. What is the ratio of the Aid flow (current US$) of France in 1969 to that in 1970?
Ensure brevity in your answer.  1.08. What is the ratio of the Aid flow (current US$) of Germany in 1969 to that in 1970?
Make the answer very short. 0.97. What is the ratio of the Aid flow (current US$) of Italy in 1969 to that in 1970?
Keep it short and to the point. 0.66. What is the ratio of the Aid flow (current US$) in Japan in 1969 to that in 1970?
Your response must be concise. 0.46. What is the ratio of the Aid flow (current US$) of France in 1969 to that in 1971?
Provide a short and direct response. 0.98. What is the ratio of the Aid flow (current US$) in Germany in 1969 to that in 1971?
Your answer should be compact. 0.99. What is the ratio of the Aid flow (current US$) of Italy in 1969 to that in 1971?
Offer a terse response. 0.6. What is the ratio of the Aid flow (current US$) in Japan in 1969 to that in 1971?
Keep it short and to the point. 0.3. What is the ratio of the Aid flow (current US$) in France in 1970 to that in 1971?
Offer a very short reply. 0.9. What is the ratio of the Aid flow (current US$) in Germany in 1970 to that in 1971?
Your response must be concise. 1.02. What is the ratio of the Aid flow (current US$) in Italy in 1970 to that in 1971?
Your response must be concise. 0.91. What is the ratio of the Aid flow (current US$) in Japan in 1970 to that in 1971?
Ensure brevity in your answer.  0.66. What is the difference between the highest and the second highest Aid flow (current US$) in France?
Offer a very short reply. 1.85e+08. What is the difference between the highest and the second highest Aid flow (current US$) in Germany?
Your response must be concise. 1.55e+06. What is the difference between the highest and the second highest Aid flow (current US$) of Italy?
Ensure brevity in your answer.  1.10e+07. What is the difference between the highest and the second highest Aid flow (current US$) of Japan?
Your answer should be compact. 4.24e+06. What is the difference between the highest and the lowest Aid flow (current US$) of France?
Ensure brevity in your answer.  2.34e+08. What is the difference between the highest and the lowest Aid flow (current US$) in Germany?
Offer a terse response. 2.55e+07. What is the difference between the highest and the lowest Aid flow (current US$) of Italy?
Offer a terse response. 4.00e+07. What is the difference between the highest and the lowest Aid flow (current US$) of Japan?
Make the answer very short. 1.18e+07. 